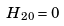<formula> <loc_0><loc_0><loc_500><loc_500>H _ { 2 0 } = 0</formula> 